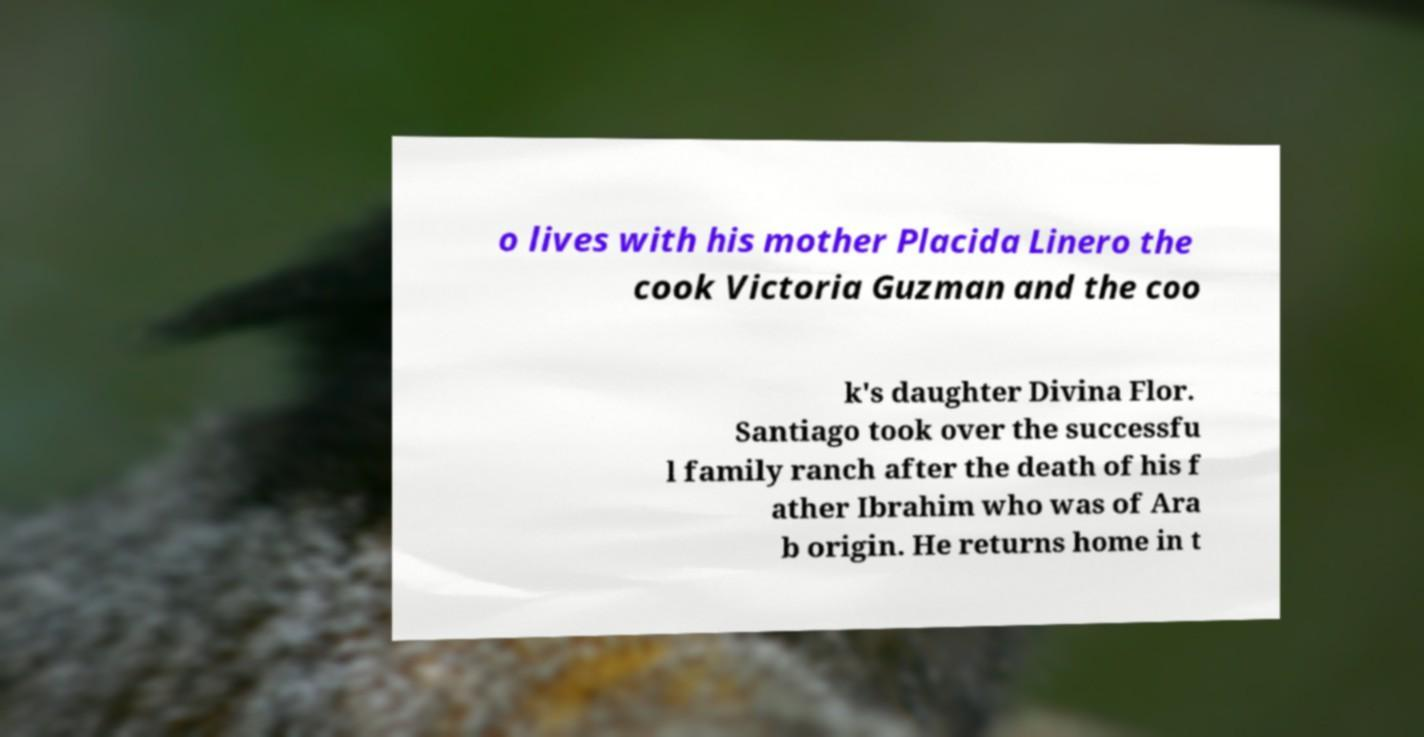Can you read and provide the text displayed in the image?This photo seems to have some interesting text. Can you extract and type it out for me? o lives with his mother Placida Linero the cook Victoria Guzman and the coo k's daughter Divina Flor. Santiago took over the successfu l family ranch after the death of his f ather Ibrahim who was of Ara b origin. He returns home in t 